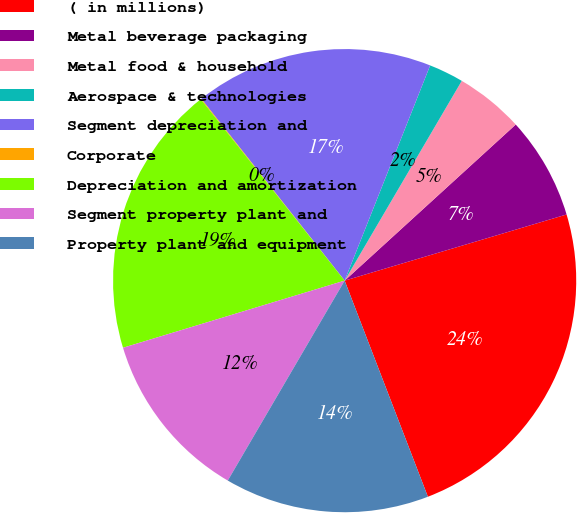Convert chart to OTSL. <chart><loc_0><loc_0><loc_500><loc_500><pie_chart><fcel>( in millions)<fcel>Metal beverage packaging<fcel>Metal food & household<fcel>Aerospace & technologies<fcel>Segment depreciation and<fcel>Corporate<fcel>Depreciation and amortization<fcel>Segment property plant and<fcel>Property plant and equipment<nl><fcel>23.76%<fcel>7.16%<fcel>4.79%<fcel>2.42%<fcel>16.64%<fcel>0.05%<fcel>19.01%<fcel>11.9%<fcel>14.27%<nl></chart> 